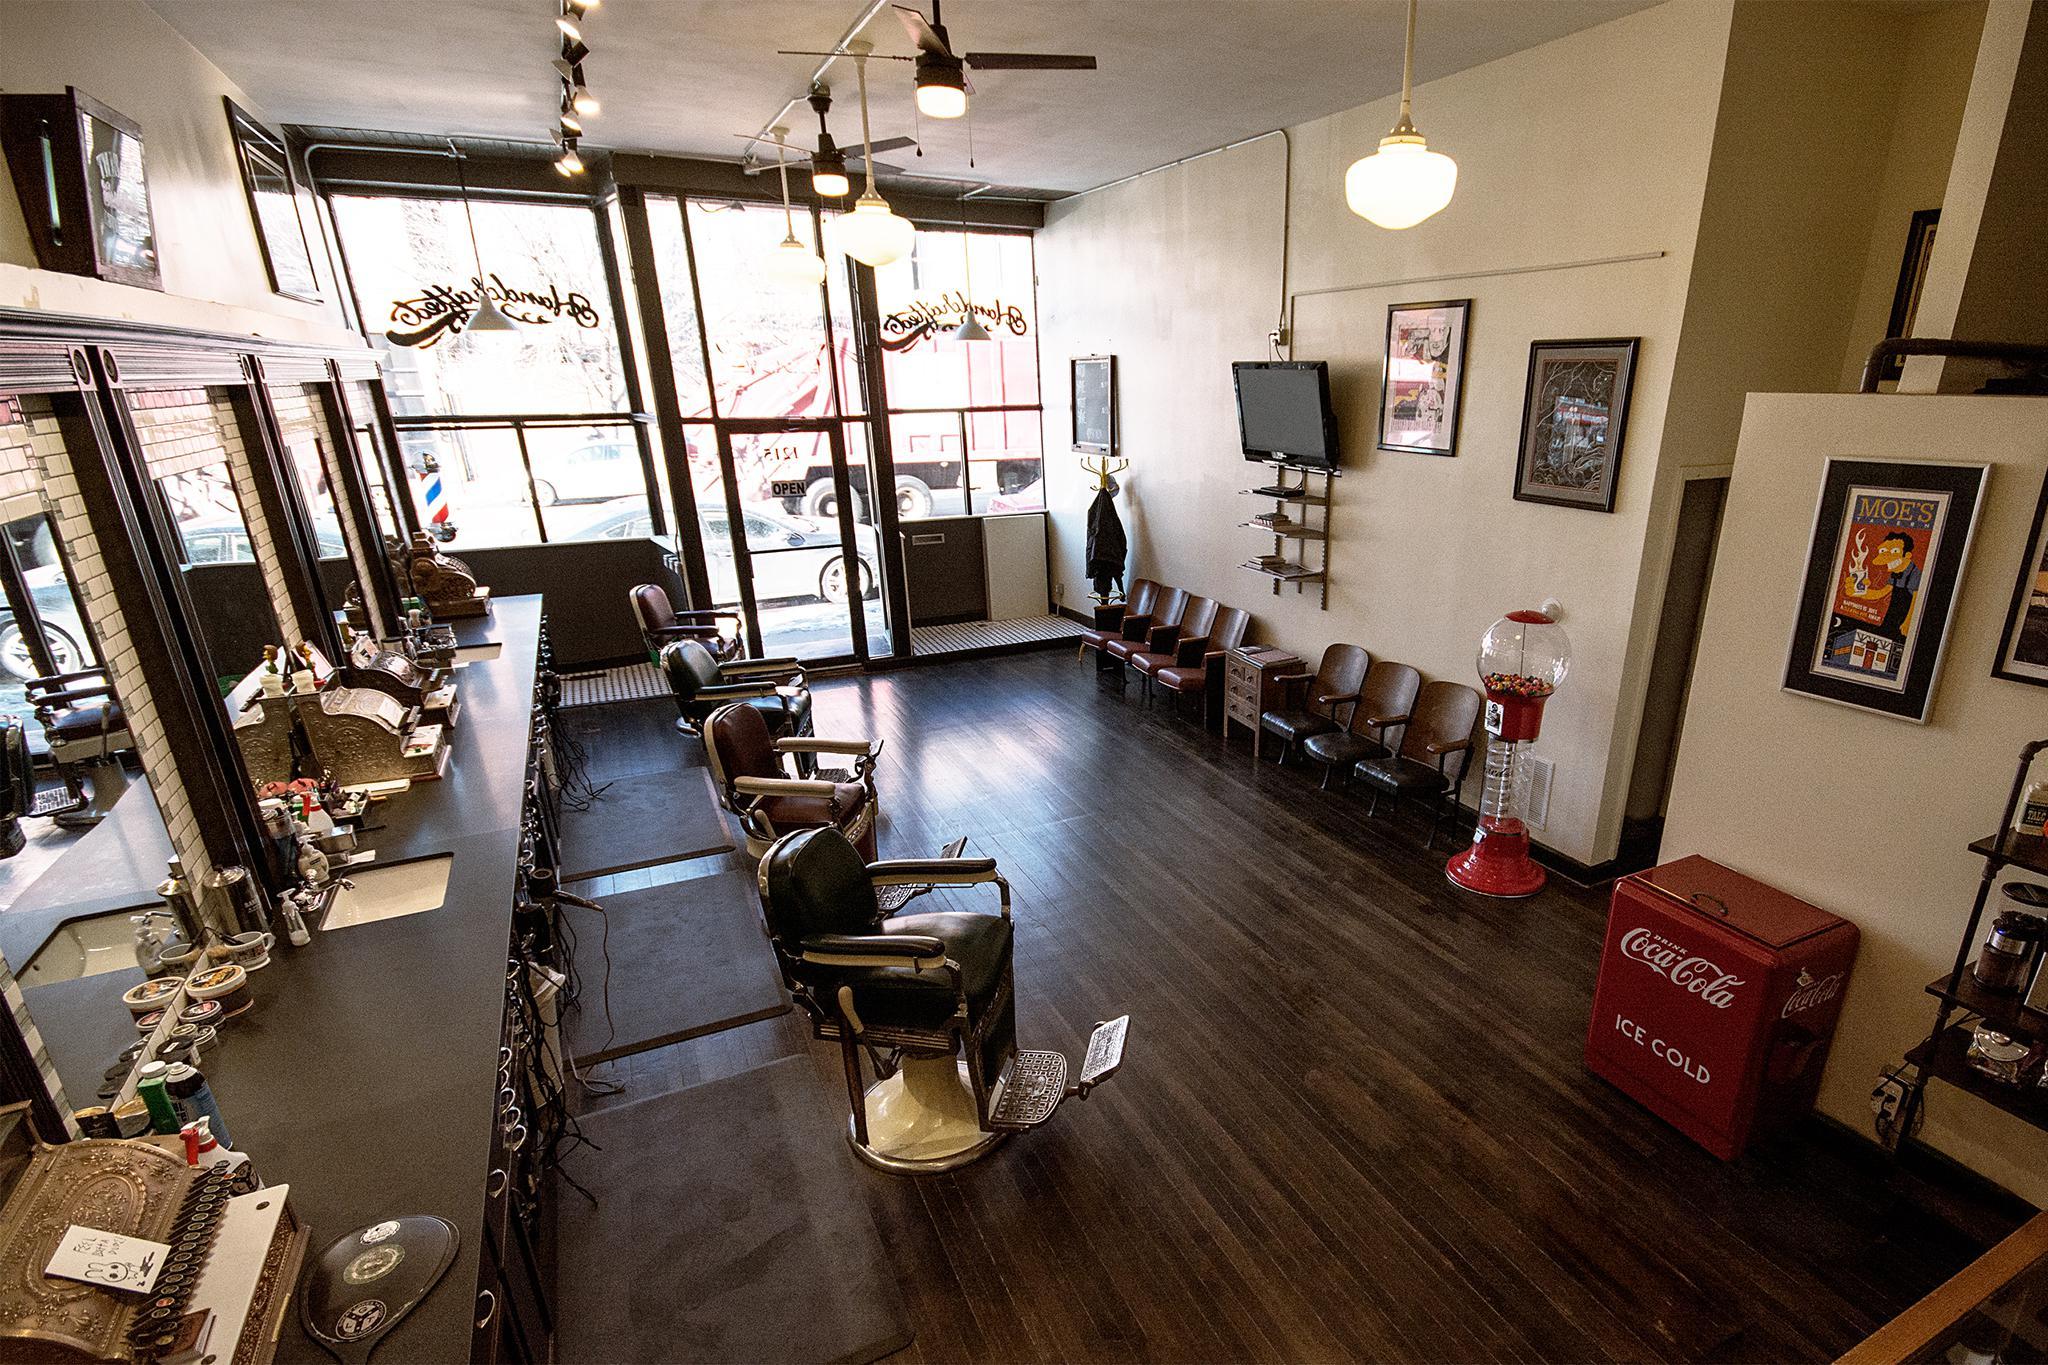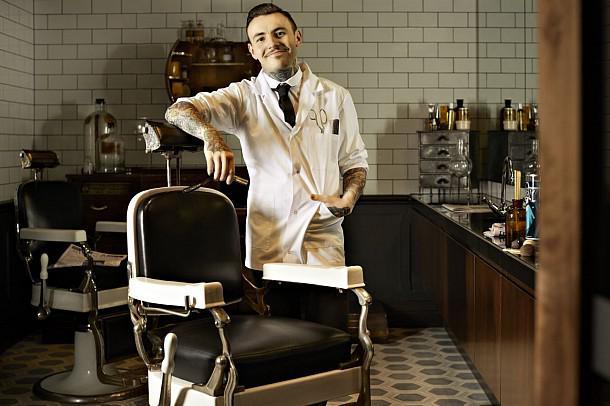The first image is the image on the left, the second image is the image on the right. Examine the images to the left and right. Is the description "One image clearly shows one barber posed with one barber chair." accurate? Answer yes or no. Yes. The first image is the image on the left, the second image is the image on the right. For the images displayed, is the sentence "there is a door in one of the images" factually correct? Answer yes or no. Yes. 